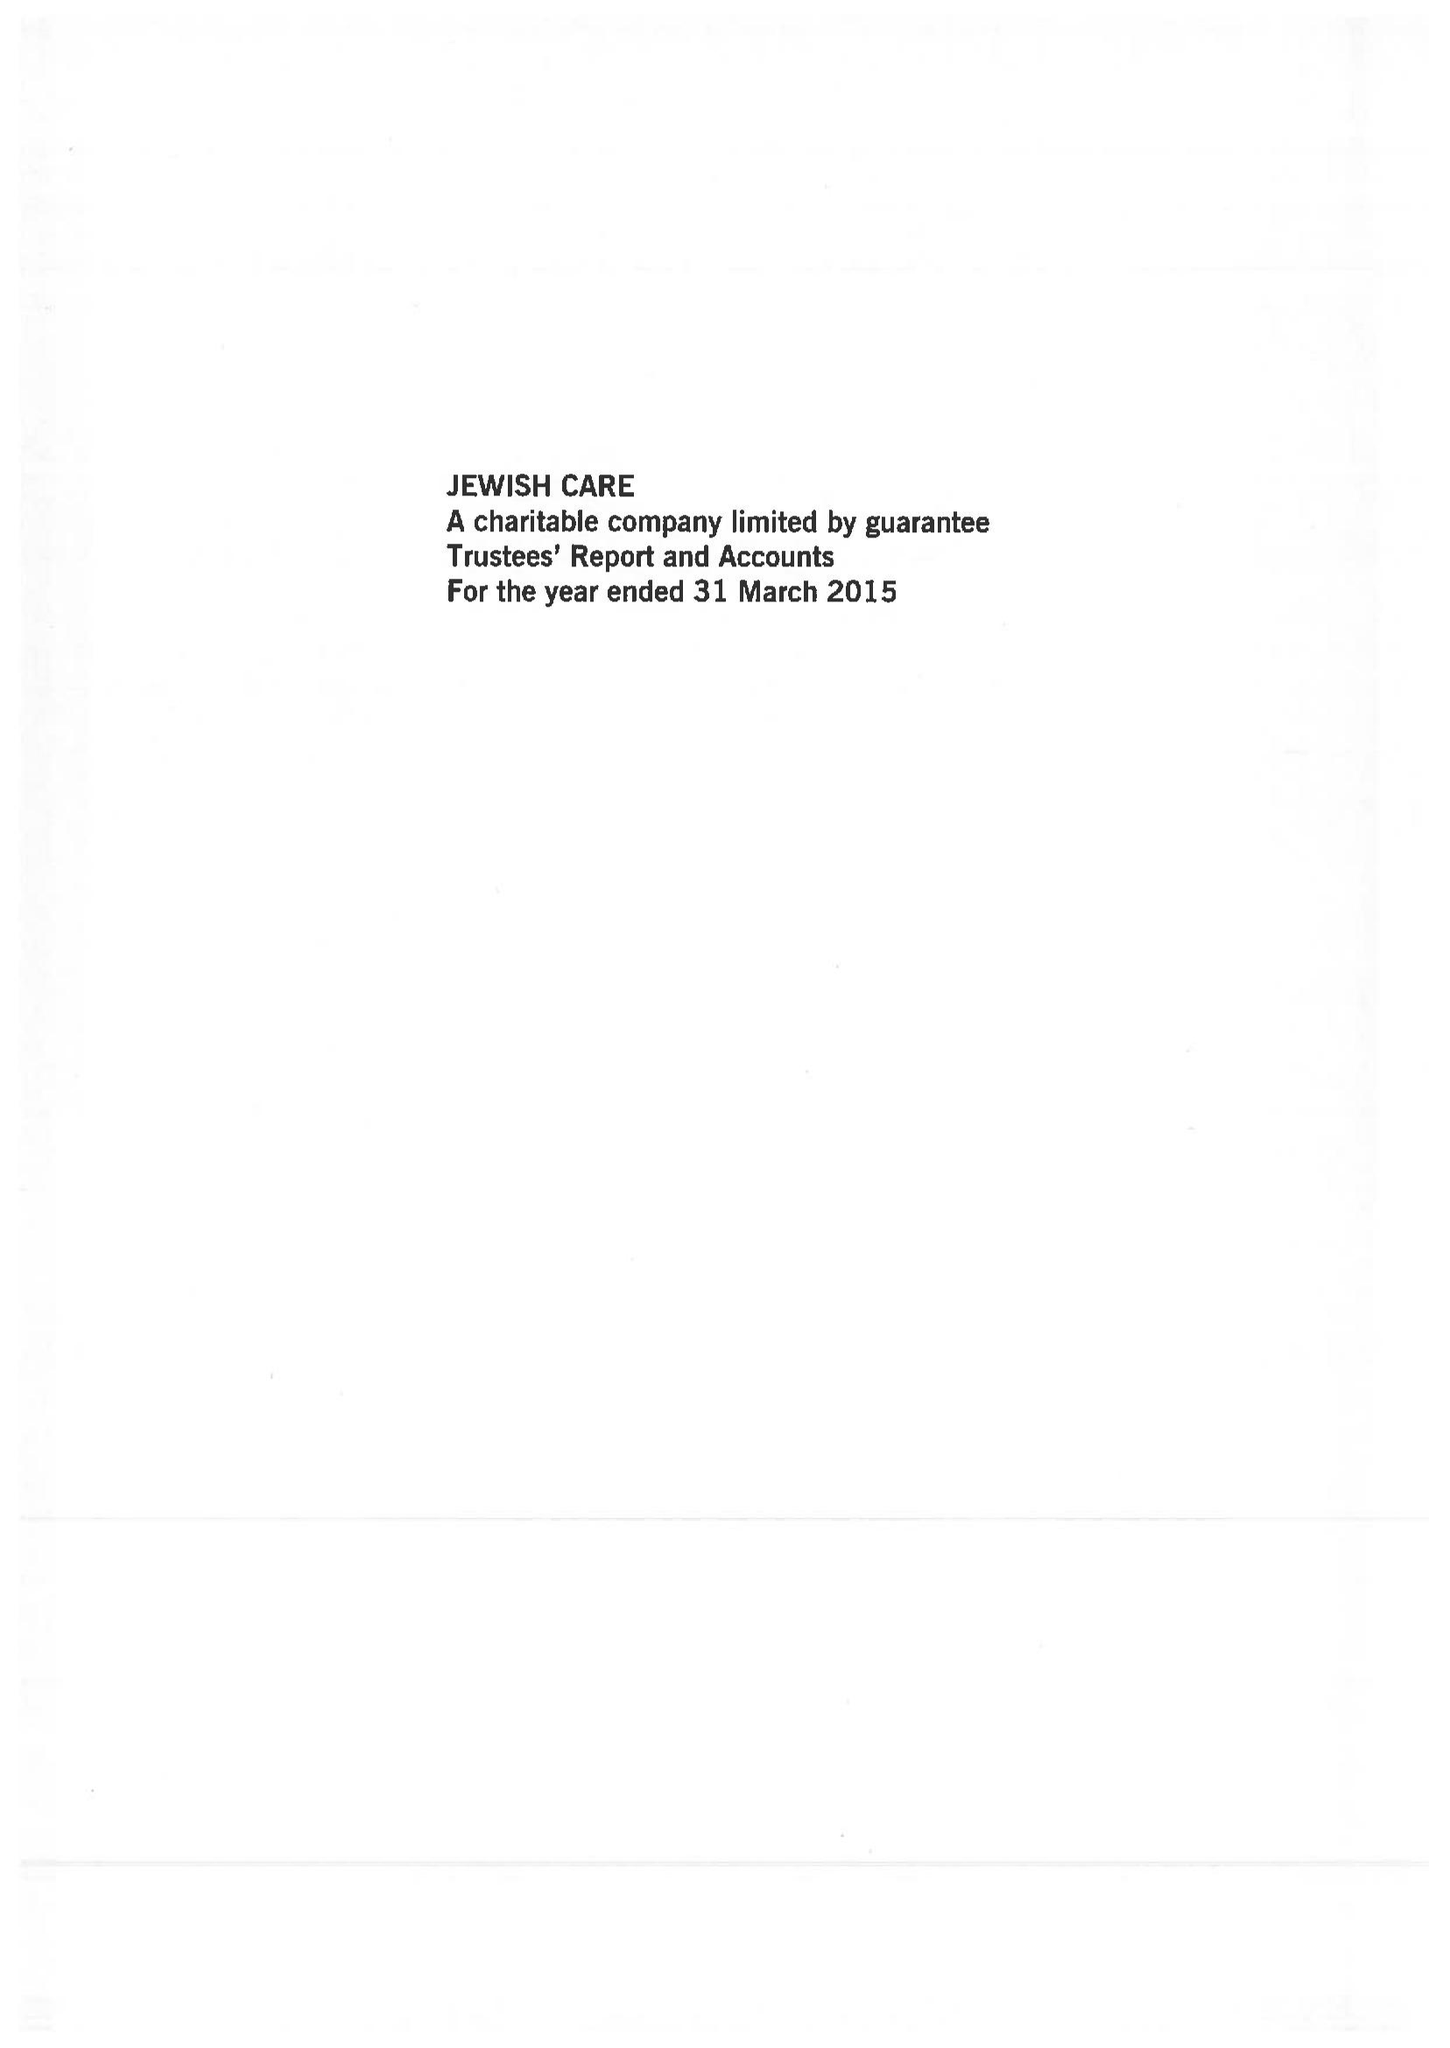What is the value for the charity_name?
Answer the question using a single word or phrase. Jewish Care 